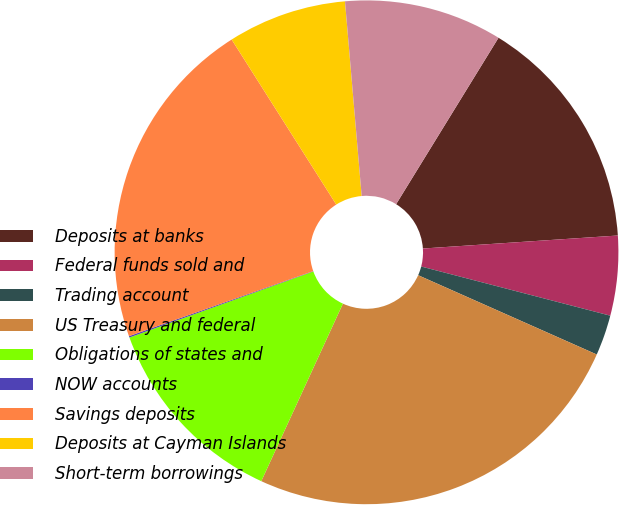Convert chart to OTSL. <chart><loc_0><loc_0><loc_500><loc_500><pie_chart><fcel>Deposits at banks<fcel>Federal funds sold and<fcel>Trading account<fcel>US Treasury and federal<fcel>Obligations of states and<fcel>NOW accounts<fcel>Savings deposits<fcel>Deposits at Cayman Islands<fcel>Short-term borrowings<nl><fcel>15.16%<fcel>5.11%<fcel>2.6%<fcel>25.21%<fcel>12.65%<fcel>0.09%<fcel>21.41%<fcel>7.63%<fcel>10.14%<nl></chart> 